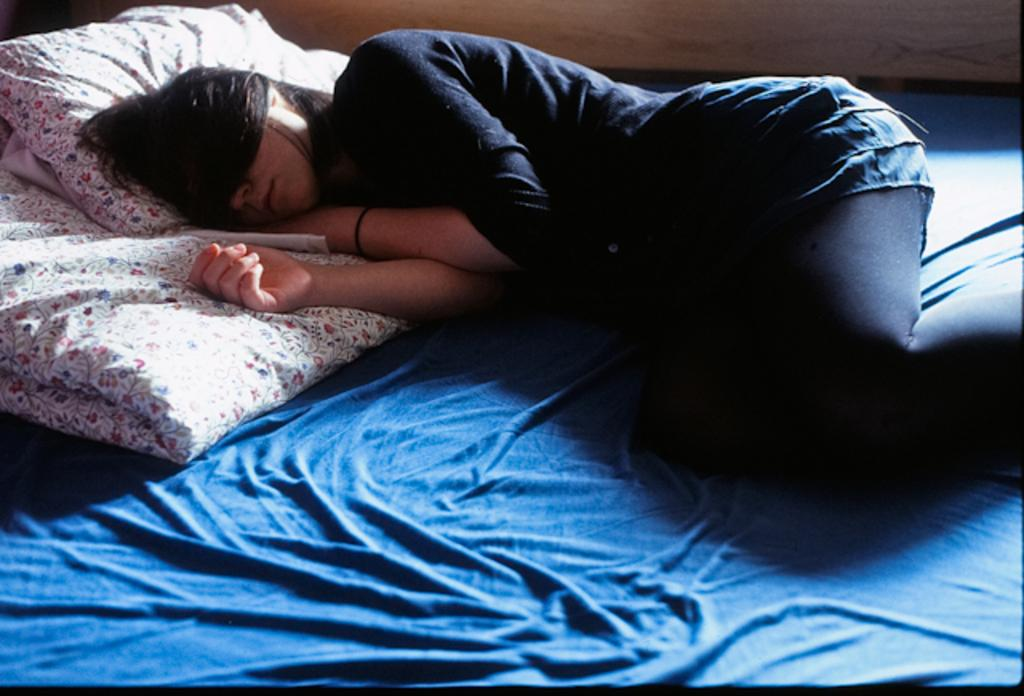Who is in the image? There is a lady in the image. What is the lady wearing? The lady is wearing a black dress. What is the lady doing in the image? The lady is lying on the bed. What type of bed sheet can be seen on the bed? There is a floral design bed sheet and a blue color bed sheet in the image. What is present on the bed besides the bed sheets? There is a pillow in the image. Where is the goat in the image? There is no goat present in the image. What type of sack is being used as a pillow in the image? There is no sack being used as a pillow in the image; there is a regular pillow present. 